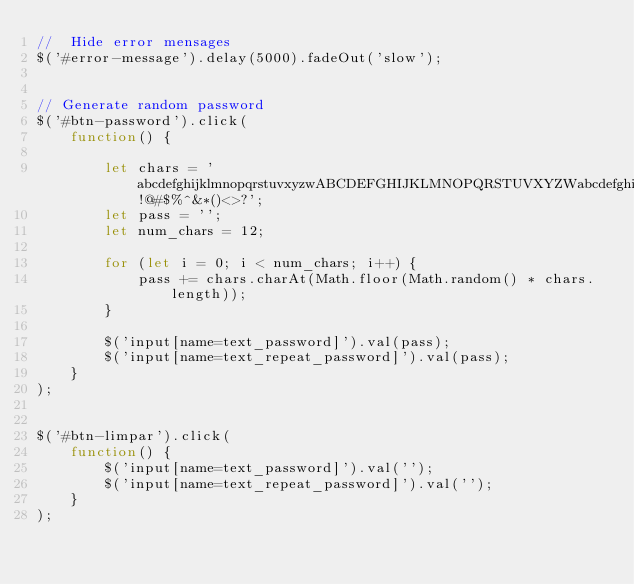Convert code to text. <code><loc_0><loc_0><loc_500><loc_500><_JavaScript_>//  Hide error mensages
$('#error-message').delay(5000).fadeOut('slow');


// Generate random password
$('#btn-password').click(
    function() {

        let chars = 'abcdefghijklmnopqrstuvxyzwABCDEFGHIJKLMNOPQRSTUVXYZWabcdefghijklmnopqrstuvxyzwABCDEFGHIJKLMNOPQRSTUVXYZW!@#$%^&*()<>?';
        let pass = '';
        let num_chars = 12;

        for (let i = 0; i < num_chars; i++) {
            pass += chars.charAt(Math.floor(Math.random() * chars.length));
        }

        $('input[name=text_password]').val(pass);
        $('input[name=text_repeat_password]').val(pass);
    }
);


$('#btn-limpar').click(
    function() {
        $('input[name=text_password]').val('');
        $('input[name=text_repeat_password]').val('');
    }
);</code> 